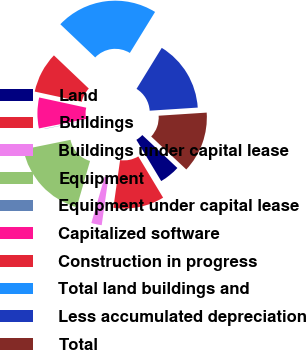<chart> <loc_0><loc_0><loc_500><loc_500><pie_chart><fcel>Land<fcel>Buildings<fcel>Buildings under capital lease<fcel>Equipment<fcel>Equipment under capital lease<fcel>Capitalized software<fcel>Construction in progress<fcel>Total land buildings and<fcel>Less accumulated depreciation<fcel>Total<nl><fcel>4.38%<fcel>10.86%<fcel>2.22%<fcel>17.35%<fcel>0.05%<fcel>6.54%<fcel>8.7%<fcel>21.67%<fcel>15.19%<fcel>13.03%<nl></chart> 